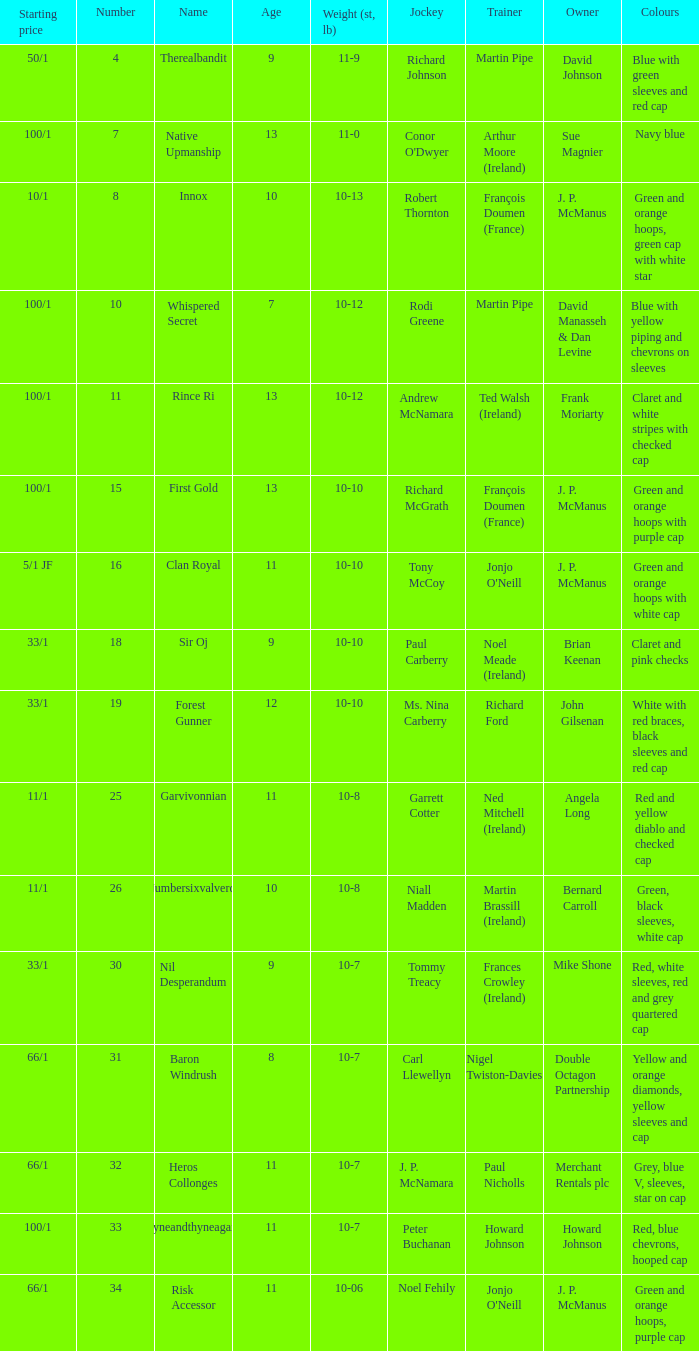What was the name of the entrant with an owner named David Johnson? Therealbandit. Parse the table in full. {'header': ['Starting price', 'Number', 'Name', 'Age', 'Weight (st, lb)', 'Jockey', 'Trainer', 'Owner', 'Colours'], 'rows': [['50/1', '4', 'Therealbandit', '9', '11-9', 'Richard Johnson', 'Martin Pipe', 'David Johnson', 'Blue with green sleeves and red cap'], ['100/1', '7', 'Native Upmanship', '13', '11-0', "Conor O'Dwyer", 'Arthur Moore (Ireland)', 'Sue Magnier', 'Navy blue'], ['10/1', '8', 'Innox', '10', '10-13', 'Robert Thornton', 'François Doumen (France)', 'J. P. McManus', 'Green and orange hoops, green cap with white star'], ['100/1', '10', 'Whispered Secret', '7', '10-12', 'Rodi Greene', 'Martin Pipe', 'David Manasseh & Dan Levine', 'Blue with yellow piping and chevrons on sleeves'], ['100/1', '11', 'Rince Ri', '13', '10-12', 'Andrew McNamara', 'Ted Walsh (Ireland)', 'Frank Moriarty', 'Claret and white stripes with checked cap'], ['100/1', '15', 'First Gold', '13', '10-10', 'Richard McGrath', 'François Doumen (France)', 'J. P. McManus', 'Green and orange hoops with purple cap'], ['5/1 JF', '16', 'Clan Royal', '11', '10-10', 'Tony McCoy', "Jonjo O'Neill", 'J. P. McManus', 'Green and orange hoops with white cap'], ['33/1', '18', 'Sir Oj', '9', '10-10', 'Paul Carberry', 'Noel Meade (Ireland)', 'Brian Keenan', 'Claret and pink checks'], ['33/1', '19', 'Forest Gunner', '12', '10-10', 'Ms. Nina Carberry', 'Richard Ford', 'John Gilsenan', 'White with red braces, black sleeves and red cap'], ['11/1', '25', 'Garvivonnian', '11', '10-8', 'Garrett Cotter', 'Ned Mitchell (Ireland)', 'Angela Long', 'Red and yellow diablo and checked cap'], ['11/1', '26', 'Numbersixvalverde', '10', '10-8', 'Niall Madden', 'Martin Brassill (Ireland)', 'Bernard Carroll', 'Green, black sleeves, white cap'], ['33/1', '30', 'Nil Desperandum', '9', '10-7', 'Tommy Treacy', 'Frances Crowley (Ireland)', 'Mike Shone', 'Red, white sleeves, red and grey quartered cap'], ['66/1', '31', 'Baron Windrush', '8', '10-7', 'Carl Llewellyn', 'Nigel Twiston-Davies', 'Double Octagon Partnership', 'Yellow and orange diamonds, yellow sleeves and cap'], ['66/1', '32', 'Heros Collonges', '11', '10-7', 'J. P. McNamara', 'Paul Nicholls', 'Merchant Rentals plc', 'Grey, blue V, sleeves, star on cap'], ['100/1', '33', 'Tyneandthyneagain', '11', '10-7', 'Peter Buchanan', 'Howard Johnson', 'Howard Johnson', 'Red, blue chevrons, hooped cap'], ['66/1', '34', 'Risk Accessor', '11', '10-06', 'Noel Fehily', "Jonjo O'Neill", 'J. P. McManus', 'Green and orange hoops, purple cap']]} 